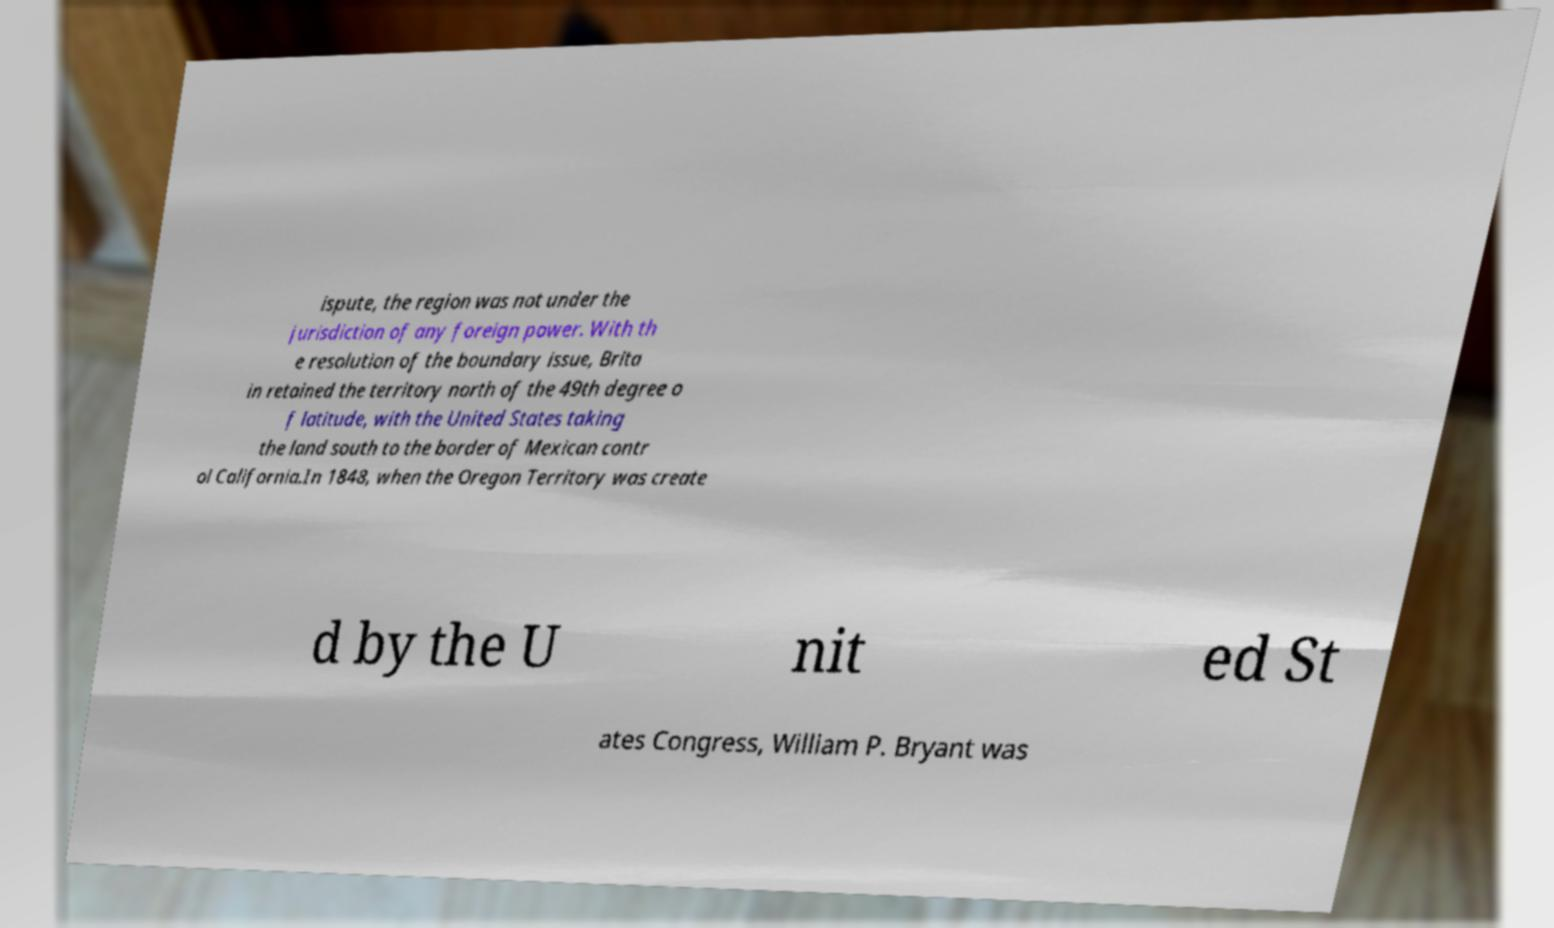Can you read and provide the text displayed in the image?This photo seems to have some interesting text. Can you extract and type it out for me? ispute, the region was not under the jurisdiction of any foreign power. With th e resolution of the boundary issue, Brita in retained the territory north of the 49th degree o f latitude, with the United States taking the land south to the border of Mexican contr ol California.In 1848, when the Oregon Territory was create d by the U nit ed St ates Congress, William P. Bryant was 